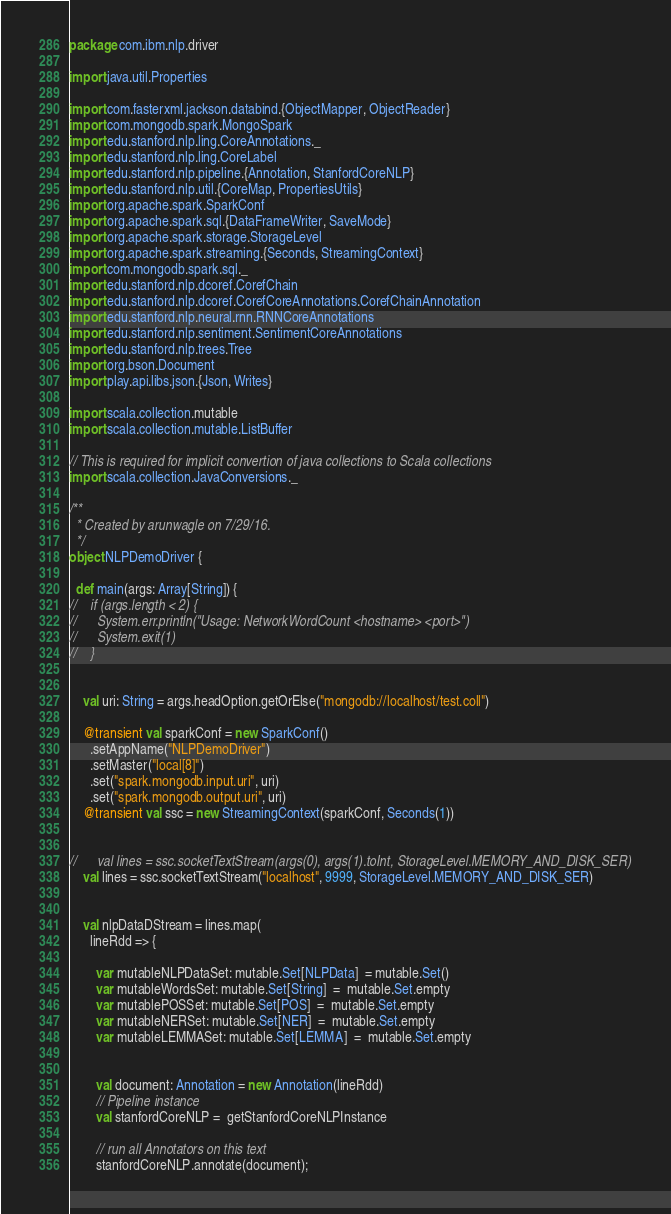<code> <loc_0><loc_0><loc_500><loc_500><_Scala_>package com.ibm.nlp.driver

import java.util.Properties

import com.fasterxml.jackson.databind.{ObjectMapper, ObjectReader}
import com.mongodb.spark.MongoSpark
import edu.stanford.nlp.ling.CoreAnnotations._
import edu.stanford.nlp.ling.CoreLabel
import edu.stanford.nlp.pipeline.{Annotation, StanfordCoreNLP}
import edu.stanford.nlp.util.{CoreMap, PropertiesUtils}
import org.apache.spark.SparkConf
import org.apache.spark.sql.{DataFrameWriter, SaveMode}
import org.apache.spark.storage.StorageLevel
import org.apache.spark.streaming.{Seconds, StreamingContext}
import com.mongodb.spark.sql._
import edu.stanford.nlp.dcoref.CorefChain
import edu.stanford.nlp.dcoref.CorefCoreAnnotations.CorefChainAnnotation
import edu.stanford.nlp.neural.rnn.RNNCoreAnnotations
import edu.stanford.nlp.sentiment.SentimentCoreAnnotations
import edu.stanford.nlp.trees.Tree
import org.bson.Document
import play.api.libs.json.{Json, Writes}

import scala.collection.mutable
import scala.collection.mutable.ListBuffer

// This is required for implicit convertion of java collections to Scala collections
import scala.collection.JavaConversions._

/**
  * Created by arunwagle on 7/29/16.
  */
object NLPDemoDriver {

  def main(args: Array[String]) {
//    if (args.length < 2) {
//      System.err.println("Usage: NetworkWordCount <hostname> <port>")
//      System.exit(1)
//    }


    val uri: String = args.headOption.getOrElse("mongodb://localhost/test.coll")

    @transient val sparkConf = new SparkConf()
      .setAppName("NLPDemoDriver")
      .setMaster("local[8]")
      .set("spark.mongodb.input.uri", uri)
      .set("spark.mongodb.output.uri", uri)
    @transient val ssc = new StreamingContext(sparkConf, Seconds(1))


//      val lines = ssc.socketTextStream(args(0), args(1).toInt, StorageLevel.MEMORY_AND_DISK_SER)
    val lines = ssc.socketTextStream("localhost", 9999, StorageLevel.MEMORY_AND_DISK_SER)


    val nlpDataDStream = lines.map(
      lineRdd => {

        var mutableNLPDataSet: mutable.Set[NLPData]  = mutable.Set()
        var mutableWordsSet: mutable.Set[String]  =  mutable.Set.empty
        var mutablePOSSet: mutable.Set[POS]  =  mutable.Set.empty
        var mutableNERSet: mutable.Set[NER]  =  mutable.Set.empty
        var mutableLEMMASet: mutable.Set[LEMMA]  =  mutable.Set.empty


        val document: Annotation = new Annotation(lineRdd)
        // Pipeline instance
        val stanfordCoreNLP =  getStanfordCoreNLPInstance

        // run all Annotators on this text
        stanfordCoreNLP.annotate(document);
</code> 